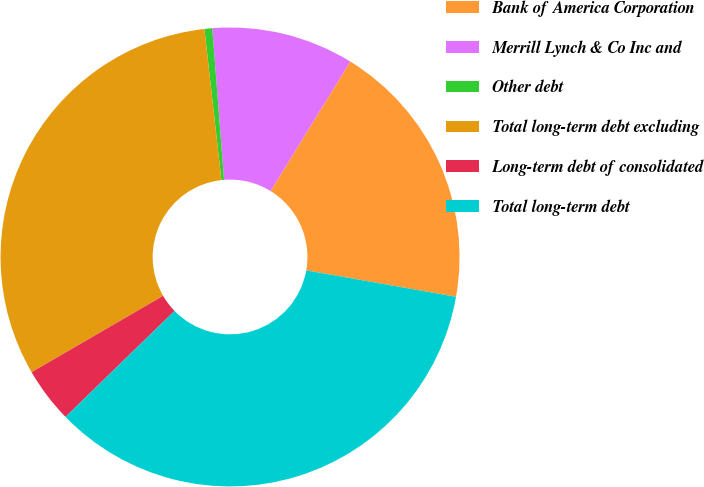Convert chart to OTSL. <chart><loc_0><loc_0><loc_500><loc_500><pie_chart><fcel>Bank of America Corporation<fcel>Merrill Lynch & Co Inc and<fcel>Other debt<fcel>Total long-term debt excluding<fcel>Long-term debt of consolidated<fcel>Total long-term debt<nl><fcel>19.0%<fcel>10.01%<fcel>0.55%<fcel>31.59%<fcel>3.9%<fcel>34.95%<nl></chart> 